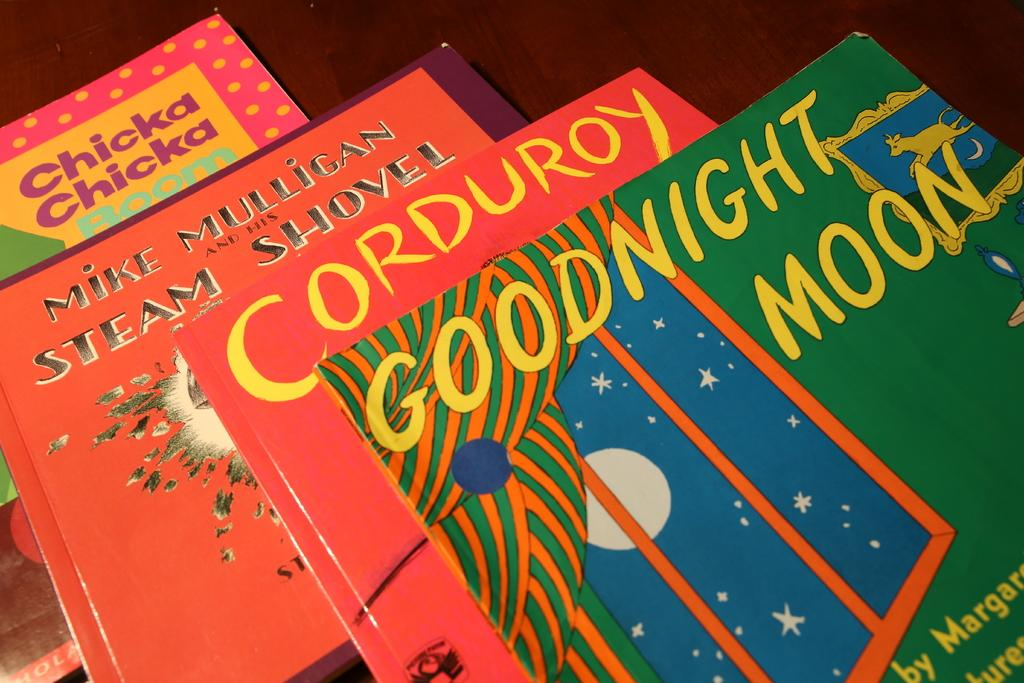<image>
Share a concise interpretation of the image provided. Several children's books including Curduroy and Goodnight Moon. 